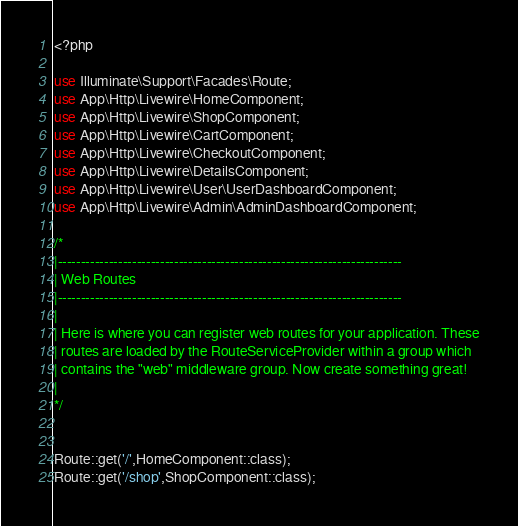<code> <loc_0><loc_0><loc_500><loc_500><_PHP_><?php

use Illuminate\Support\Facades\Route;
use App\Http\Livewire\HomeComponent;
use App\Http\Livewire\ShopComponent;
use App\Http\Livewire\CartComponent;
use App\Http\Livewire\CheckoutComponent;
use App\Http\Livewire\DetailsComponent;
use App\Http\Livewire\User\UserDashboardComponent;
use App\Http\Livewire\Admin\AdminDashboardComponent;

/*
|--------------------------------------------------------------------------
| Web Routes
|--------------------------------------------------------------------------
|
| Here is where you can register web routes for your application. These
| routes are loaded by the RouteServiceProvider within a group which
| contains the "web" middleware group. Now create something great!
|
*/


Route::get('/',HomeComponent::class);
Route::get('/shop',ShopComponent::class);</code> 